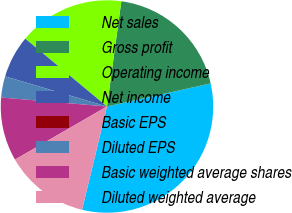<chart> <loc_0><loc_0><loc_500><loc_500><pie_chart><fcel>Net sales<fcel>Gross profit<fcel>Operating income<fcel>Net income<fcel>Basic EPS<fcel>Diluted EPS<fcel>Basic weighted average shares<fcel>Diluted weighted average<nl><fcel>32.26%<fcel>19.35%<fcel>16.13%<fcel>6.45%<fcel>0.0%<fcel>3.23%<fcel>9.68%<fcel>12.9%<nl></chart> 